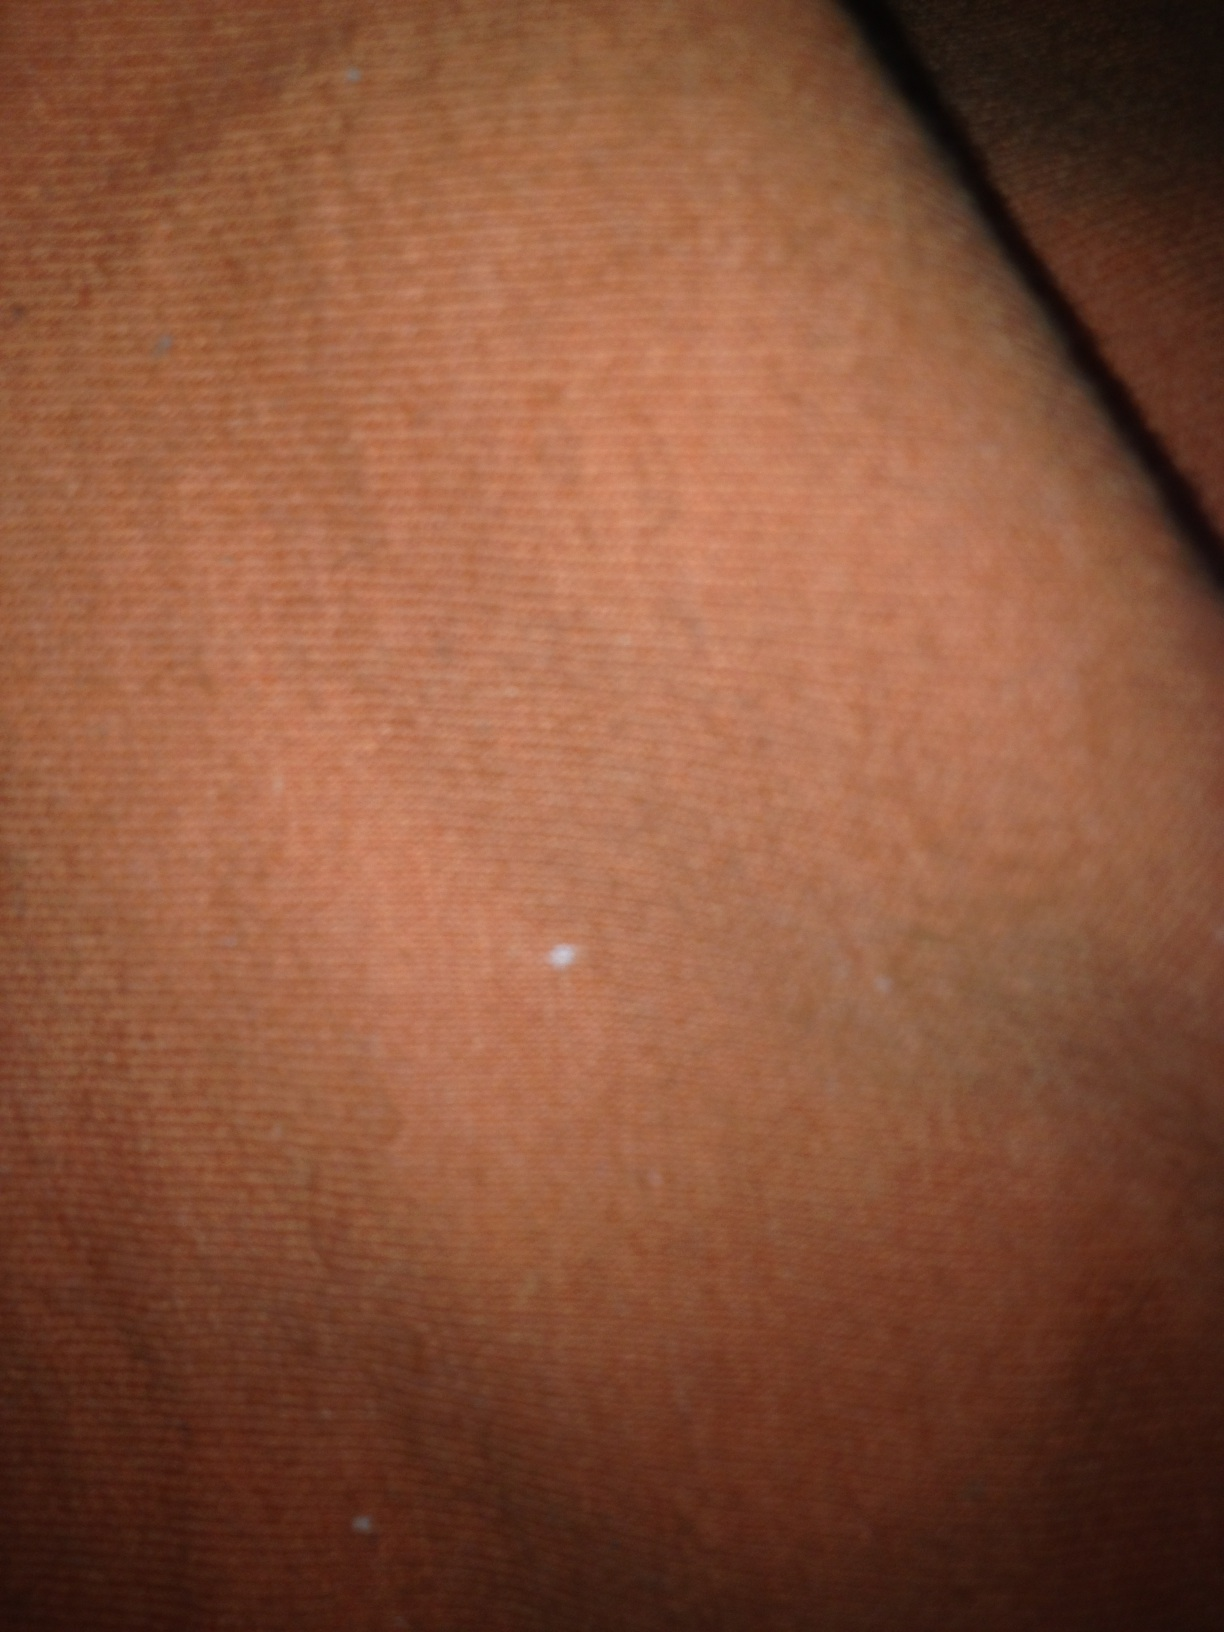Imagine if this fabric came to life, what might it do? If this fabric came to life, it might flutter around like a flag in the breeze, or perhaps reshape itself into different forms and patterns. It could move to provide comfort by wrapping around someone or transforming into a cozy blanket. Can you create a short story about this fabric coming to life? Once upon a time, in a quaint little tailor’s shop, there was a bolt of beautiful orange fabric. This fabric was enchanted and one night, under the light of a full moon, it came to life. The fabric danced around the shop, weaving itself through shelves and displays. It rearranged the shop, turning clutter into artful displays. The tailor awoke to find his shop transformed and knew that this magical fabric was destined for something special. He crafted it into a jacket, and whoever wore the jacket felt an undeniable sense of joy and creativity, inspiring them to achieve great things. The magic of the fabric was known far and wide, bringing beauty and happiness to all who encountered it. 